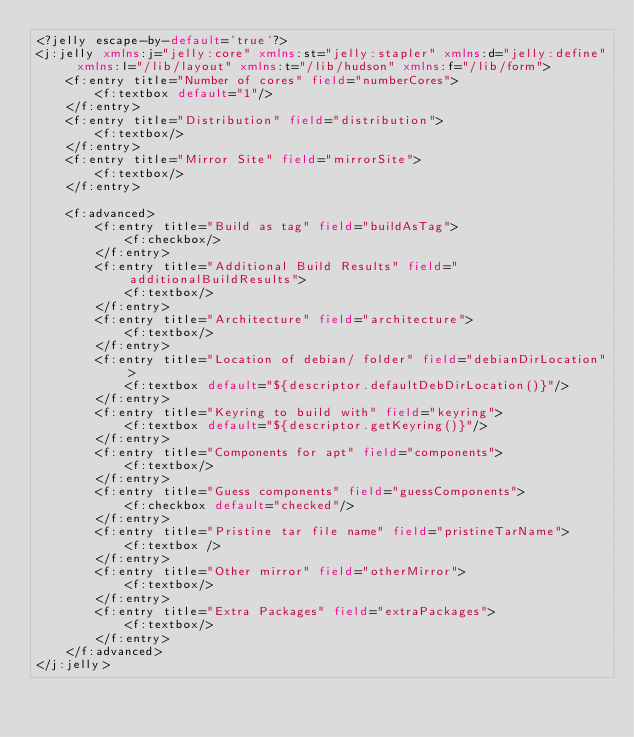Convert code to text. <code><loc_0><loc_0><loc_500><loc_500><_XML_><?jelly escape-by-default='true'?>
<j:jelly xmlns:j="jelly:core" xmlns:st="jelly:stapler" xmlns:d="jelly:define" xmlns:l="/lib/layout" xmlns:t="/lib/hudson" xmlns:f="/lib/form">
    <f:entry title="Number of cores" field="numberCores">
        <f:textbox default="1"/>
    </f:entry>
    <f:entry title="Distribution" field="distribution">
        <f:textbox/>
    </f:entry>
    <f:entry title="Mirror Site" field="mirrorSite">
        <f:textbox/>
    </f:entry>

    <f:advanced>
        <f:entry title="Build as tag" field="buildAsTag">
            <f:checkbox/>
        </f:entry>
        <f:entry title="Additional Build Results" field="additionalBuildResults">
            <f:textbox/>
        </f:entry>
        <f:entry title="Architecture" field="architecture">
            <f:textbox/>
        </f:entry>
        <f:entry title="Location of debian/ folder" field="debianDirLocation">
            <f:textbox default="${descriptor.defaultDebDirLocation()}"/>
        </f:entry>
        <f:entry title="Keyring to build with" field="keyring">
            <f:textbox default="${descriptor.getKeyring()}"/>
        </f:entry>
        <f:entry title="Components for apt" field="components">
            <f:textbox/>
        </f:entry>
        <f:entry title="Guess components" field="guessComponents">
            <f:checkbox default="checked"/>
        </f:entry>
        <f:entry title="Pristine tar file name" field="pristineTarName">
            <f:textbox />
        </f:entry>
        <f:entry title="Other mirror" field="otherMirror">
            <f:textbox/>
        </f:entry>
        <f:entry title="Extra Packages" field="extraPackages">
            <f:textbox/>
        </f:entry>
    </f:advanced>
</j:jelly>
</code> 